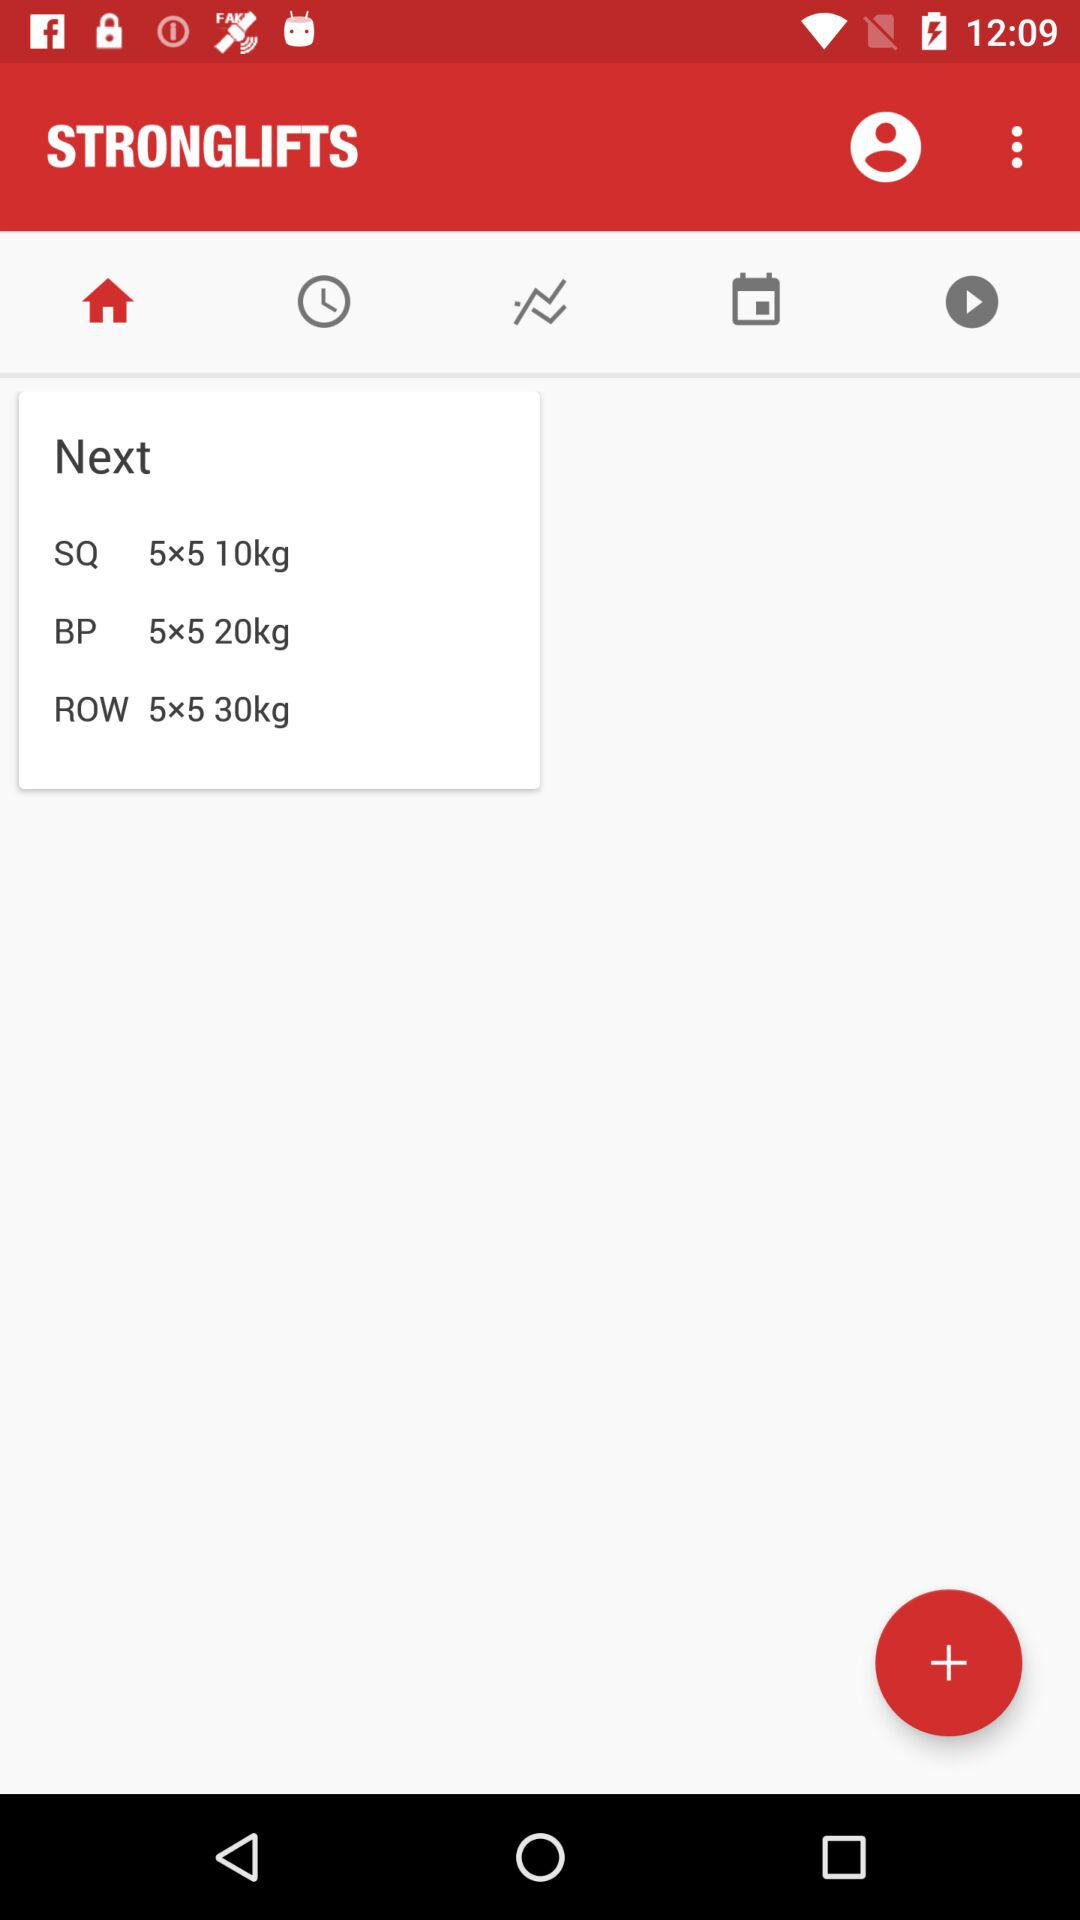Which tab is currently selected? The currently selected tab is "Home". 